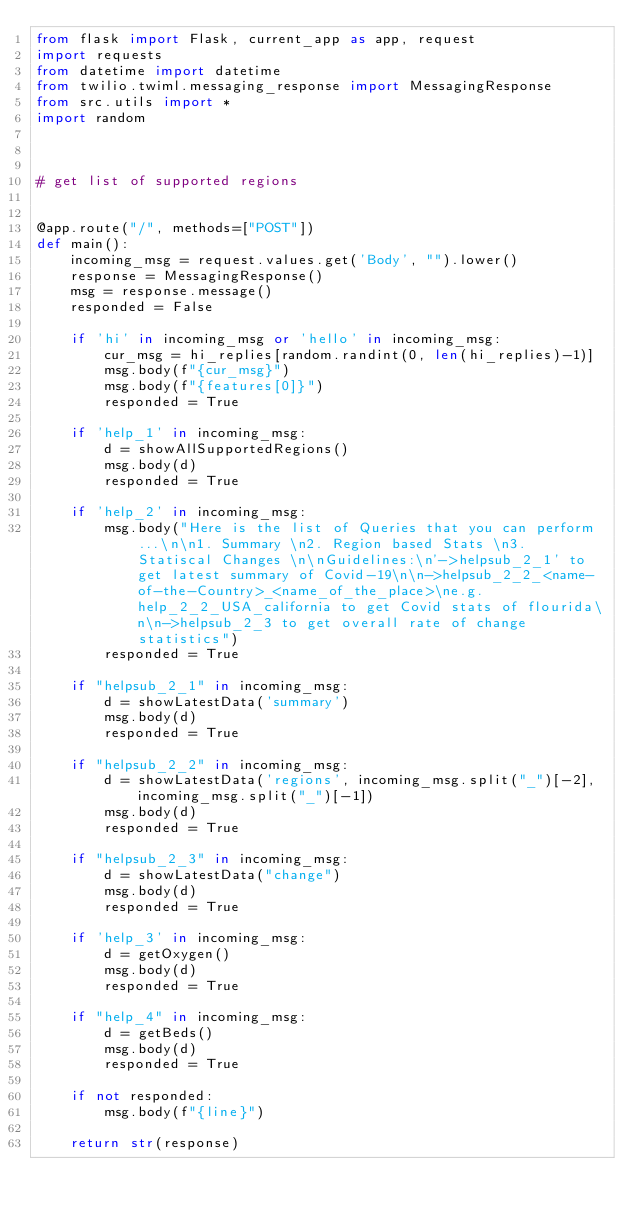Convert code to text. <code><loc_0><loc_0><loc_500><loc_500><_Python_>from flask import Flask, current_app as app, request
import requests
from datetime import datetime
from twilio.twiml.messaging_response import MessagingResponse
from src.utils import *
import random



# get list of supported regions


@app.route("/", methods=["POST"])
def main():
    incoming_msg = request.values.get('Body', "").lower()
    response = MessagingResponse()
    msg = response.message()
    responded = False

    if 'hi' in incoming_msg or 'hello' in incoming_msg:
        cur_msg = hi_replies[random.randint(0, len(hi_replies)-1)]
        msg.body(f"{cur_msg}")
        msg.body(f"{features[0]}")
        responded = True

    if 'help_1' in incoming_msg:
        d = showAllSupportedRegions()
        msg.body(d)
        responded = True

    if 'help_2' in incoming_msg:
        msg.body("Here is the list of Queries that you can perform...\n\n1. Summary \n2. Region based Stats \n3. Statiscal Changes \n\nGuidelines:\n'->helpsub_2_1' to get latest summary of Covid-19\n\n->helpsub_2_2_<name-of-the-Country>_<name_of_the_place>\ne.g. help_2_2_USA_california to get Covid stats of flourida\n\n->helpsub_2_3 to get overall rate of change statistics")
        responded = True

    if "helpsub_2_1" in incoming_msg:
        d = showLatestData('summary')
        msg.body(d)
        responded = True
    
    if "helpsub_2_2" in incoming_msg:
        d = showLatestData('regions', incoming_msg.split("_")[-2], incoming_msg.split("_")[-1])
        msg.body(d)
        responded = True
    
    if "helpsub_2_3" in incoming_msg:
        d = showLatestData("change")
        msg.body(d)
        responded = True

    if 'help_3' in incoming_msg:
        d = getOxygen()
        msg.body(d)
        responded = True
    
    if "help_4" in incoming_msg:
        d = getBeds()
        msg.body(d)
        responded = True

    if not responded:
        msg.body(f"{line}")

    return str(response)
</code> 